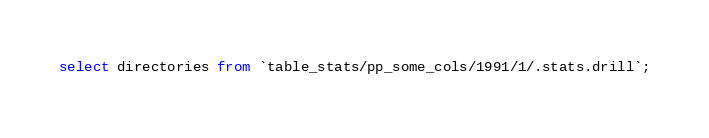Convert code to text. <code><loc_0><loc_0><loc_500><loc_500><_SQL_>select directories from `table_stats/pp_some_cols/1991/1/.stats.drill`;</code> 